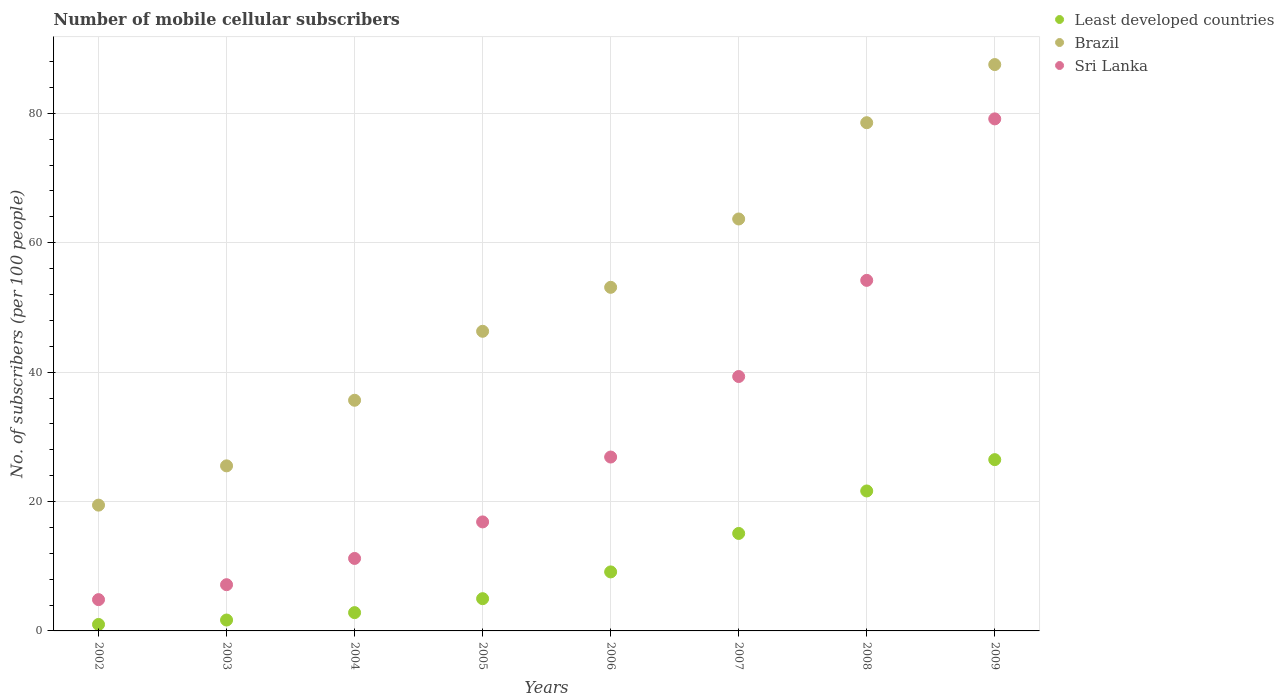How many different coloured dotlines are there?
Make the answer very short. 3. Is the number of dotlines equal to the number of legend labels?
Provide a succinct answer. Yes. What is the number of mobile cellular subscribers in Brazil in 2002?
Provide a succinct answer. 19.44. Across all years, what is the maximum number of mobile cellular subscribers in Sri Lanka?
Your answer should be very brief. 79.15. Across all years, what is the minimum number of mobile cellular subscribers in Least developed countries?
Provide a succinct answer. 1. In which year was the number of mobile cellular subscribers in Sri Lanka minimum?
Your answer should be very brief. 2002. What is the total number of mobile cellular subscribers in Least developed countries in the graph?
Provide a short and direct response. 82.79. What is the difference between the number of mobile cellular subscribers in Brazil in 2003 and that in 2005?
Provide a succinct answer. -20.8. What is the difference between the number of mobile cellular subscribers in Sri Lanka in 2004 and the number of mobile cellular subscribers in Brazil in 2003?
Your response must be concise. -14.31. What is the average number of mobile cellular subscribers in Sri Lanka per year?
Keep it short and to the point. 29.95. In the year 2003, what is the difference between the number of mobile cellular subscribers in Least developed countries and number of mobile cellular subscribers in Brazil?
Offer a terse response. -23.83. In how many years, is the number of mobile cellular subscribers in Brazil greater than 32?
Your response must be concise. 6. What is the ratio of the number of mobile cellular subscribers in Sri Lanka in 2006 to that in 2007?
Keep it short and to the point. 0.68. What is the difference between the highest and the second highest number of mobile cellular subscribers in Sri Lanka?
Your answer should be very brief. 24.96. What is the difference between the highest and the lowest number of mobile cellular subscribers in Least developed countries?
Your response must be concise. 25.47. How many years are there in the graph?
Make the answer very short. 8. What is the difference between two consecutive major ticks on the Y-axis?
Provide a short and direct response. 20. Are the values on the major ticks of Y-axis written in scientific E-notation?
Provide a short and direct response. No. Does the graph contain grids?
Offer a terse response. Yes. Where does the legend appear in the graph?
Provide a short and direct response. Top right. How many legend labels are there?
Offer a very short reply. 3. What is the title of the graph?
Offer a terse response. Number of mobile cellular subscribers. What is the label or title of the Y-axis?
Give a very brief answer. No. of subscribers (per 100 people). What is the No. of subscribers (per 100 people) in Least developed countries in 2002?
Provide a short and direct response. 1. What is the No. of subscribers (per 100 people) in Brazil in 2002?
Provide a succinct answer. 19.44. What is the No. of subscribers (per 100 people) in Sri Lanka in 2002?
Offer a very short reply. 4.84. What is the No. of subscribers (per 100 people) in Least developed countries in 2003?
Keep it short and to the point. 1.68. What is the No. of subscribers (per 100 people) of Brazil in 2003?
Your answer should be very brief. 25.51. What is the No. of subscribers (per 100 people) in Sri Lanka in 2003?
Provide a succinct answer. 7.14. What is the No. of subscribers (per 100 people) in Least developed countries in 2004?
Keep it short and to the point. 2.83. What is the No. of subscribers (per 100 people) in Brazil in 2004?
Keep it short and to the point. 35.65. What is the No. of subscribers (per 100 people) of Sri Lanka in 2004?
Your answer should be very brief. 11.2. What is the No. of subscribers (per 100 people) in Least developed countries in 2005?
Provide a short and direct response. 4.98. What is the No. of subscribers (per 100 people) in Brazil in 2005?
Provide a succinct answer. 46.31. What is the No. of subscribers (per 100 people) of Sri Lanka in 2005?
Your answer should be compact. 16.85. What is the No. of subscribers (per 100 people) in Least developed countries in 2006?
Provide a short and direct response. 9.12. What is the No. of subscribers (per 100 people) in Brazil in 2006?
Offer a very short reply. 53.11. What is the No. of subscribers (per 100 people) of Sri Lanka in 2006?
Provide a succinct answer. 26.88. What is the No. of subscribers (per 100 people) in Least developed countries in 2007?
Your answer should be very brief. 15.07. What is the No. of subscribers (per 100 people) of Brazil in 2007?
Your answer should be compact. 63.67. What is the No. of subscribers (per 100 people) in Sri Lanka in 2007?
Ensure brevity in your answer.  39.32. What is the No. of subscribers (per 100 people) of Least developed countries in 2008?
Your answer should be very brief. 21.63. What is the No. of subscribers (per 100 people) of Brazil in 2008?
Give a very brief answer. 78.55. What is the No. of subscribers (per 100 people) of Sri Lanka in 2008?
Your response must be concise. 54.19. What is the No. of subscribers (per 100 people) of Least developed countries in 2009?
Your answer should be very brief. 26.48. What is the No. of subscribers (per 100 people) in Brazil in 2009?
Provide a short and direct response. 87.54. What is the No. of subscribers (per 100 people) in Sri Lanka in 2009?
Ensure brevity in your answer.  79.15. Across all years, what is the maximum No. of subscribers (per 100 people) in Least developed countries?
Offer a terse response. 26.48. Across all years, what is the maximum No. of subscribers (per 100 people) in Brazil?
Provide a short and direct response. 87.54. Across all years, what is the maximum No. of subscribers (per 100 people) in Sri Lanka?
Provide a succinct answer. 79.15. Across all years, what is the minimum No. of subscribers (per 100 people) in Least developed countries?
Keep it short and to the point. 1. Across all years, what is the minimum No. of subscribers (per 100 people) of Brazil?
Your answer should be compact. 19.44. Across all years, what is the minimum No. of subscribers (per 100 people) in Sri Lanka?
Your response must be concise. 4.84. What is the total No. of subscribers (per 100 people) in Least developed countries in the graph?
Your answer should be very brief. 82.79. What is the total No. of subscribers (per 100 people) in Brazil in the graph?
Offer a terse response. 409.81. What is the total No. of subscribers (per 100 people) in Sri Lanka in the graph?
Offer a very short reply. 239.57. What is the difference between the No. of subscribers (per 100 people) in Least developed countries in 2002 and that in 2003?
Your response must be concise. -0.68. What is the difference between the No. of subscribers (per 100 people) of Brazil in 2002 and that in 2003?
Give a very brief answer. -6.07. What is the difference between the No. of subscribers (per 100 people) in Sri Lanka in 2002 and that in 2003?
Your answer should be compact. -2.31. What is the difference between the No. of subscribers (per 100 people) of Least developed countries in 2002 and that in 2004?
Your answer should be very brief. -1.83. What is the difference between the No. of subscribers (per 100 people) of Brazil in 2002 and that in 2004?
Your answer should be compact. -16.21. What is the difference between the No. of subscribers (per 100 people) in Sri Lanka in 2002 and that in 2004?
Your answer should be compact. -6.37. What is the difference between the No. of subscribers (per 100 people) of Least developed countries in 2002 and that in 2005?
Offer a terse response. -3.98. What is the difference between the No. of subscribers (per 100 people) in Brazil in 2002 and that in 2005?
Provide a succinct answer. -26.87. What is the difference between the No. of subscribers (per 100 people) in Sri Lanka in 2002 and that in 2005?
Your response must be concise. -12.01. What is the difference between the No. of subscribers (per 100 people) of Least developed countries in 2002 and that in 2006?
Offer a very short reply. -8.12. What is the difference between the No. of subscribers (per 100 people) in Brazil in 2002 and that in 2006?
Your response must be concise. -33.67. What is the difference between the No. of subscribers (per 100 people) in Sri Lanka in 2002 and that in 2006?
Your response must be concise. -22.04. What is the difference between the No. of subscribers (per 100 people) of Least developed countries in 2002 and that in 2007?
Offer a very short reply. -14.07. What is the difference between the No. of subscribers (per 100 people) of Brazil in 2002 and that in 2007?
Provide a short and direct response. -44.23. What is the difference between the No. of subscribers (per 100 people) of Sri Lanka in 2002 and that in 2007?
Provide a succinct answer. -34.49. What is the difference between the No. of subscribers (per 100 people) of Least developed countries in 2002 and that in 2008?
Give a very brief answer. -20.63. What is the difference between the No. of subscribers (per 100 people) of Brazil in 2002 and that in 2008?
Ensure brevity in your answer.  -59.11. What is the difference between the No. of subscribers (per 100 people) in Sri Lanka in 2002 and that in 2008?
Your answer should be compact. -49.35. What is the difference between the No. of subscribers (per 100 people) in Least developed countries in 2002 and that in 2009?
Offer a very short reply. -25.47. What is the difference between the No. of subscribers (per 100 people) of Brazil in 2002 and that in 2009?
Give a very brief answer. -68.1. What is the difference between the No. of subscribers (per 100 people) in Sri Lanka in 2002 and that in 2009?
Make the answer very short. -74.31. What is the difference between the No. of subscribers (per 100 people) of Least developed countries in 2003 and that in 2004?
Ensure brevity in your answer.  -1.14. What is the difference between the No. of subscribers (per 100 people) of Brazil in 2003 and that in 2004?
Provide a short and direct response. -10.14. What is the difference between the No. of subscribers (per 100 people) in Sri Lanka in 2003 and that in 2004?
Your answer should be very brief. -4.06. What is the difference between the No. of subscribers (per 100 people) in Least developed countries in 2003 and that in 2005?
Keep it short and to the point. -3.3. What is the difference between the No. of subscribers (per 100 people) in Brazil in 2003 and that in 2005?
Provide a short and direct response. -20.8. What is the difference between the No. of subscribers (per 100 people) of Sri Lanka in 2003 and that in 2005?
Your response must be concise. -9.71. What is the difference between the No. of subscribers (per 100 people) of Least developed countries in 2003 and that in 2006?
Your response must be concise. -7.44. What is the difference between the No. of subscribers (per 100 people) in Brazil in 2003 and that in 2006?
Offer a terse response. -27.6. What is the difference between the No. of subscribers (per 100 people) of Sri Lanka in 2003 and that in 2006?
Provide a succinct answer. -19.73. What is the difference between the No. of subscribers (per 100 people) in Least developed countries in 2003 and that in 2007?
Offer a terse response. -13.38. What is the difference between the No. of subscribers (per 100 people) of Brazil in 2003 and that in 2007?
Provide a succinct answer. -38.16. What is the difference between the No. of subscribers (per 100 people) in Sri Lanka in 2003 and that in 2007?
Give a very brief answer. -32.18. What is the difference between the No. of subscribers (per 100 people) of Least developed countries in 2003 and that in 2008?
Make the answer very short. -19.95. What is the difference between the No. of subscribers (per 100 people) of Brazil in 2003 and that in 2008?
Your answer should be very brief. -53.04. What is the difference between the No. of subscribers (per 100 people) of Sri Lanka in 2003 and that in 2008?
Your answer should be compact. -47.04. What is the difference between the No. of subscribers (per 100 people) of Least developed countries in 2003 and that in 2009?
Provide a short and direct response. -24.79. What is the difference between the No. of subscribers (per 100 people) in Brazil in 2003 and that in 2009?
Ensure brevity in your answer.  -62.03. What is the difference between the No. of subscribers (per 100 people) in Sri Lanka in 2003 and that in 2009?
Your answer should be compact. -72. What is the difference between the No. of subscribers (per 100 people) of Least developed countries in 2004 and that in 2005?
Make the answer very short. -2.16. What is the difference between the No. of subscribers (per 100 people) in Brazil in 2004 and that in 2005?
Give a very brief answer. -10.66. What is the difference between the No. of subscribers (per 100 people) of Sri Lanka in 2004 and that in 2005?
Offer a terse response. -5.65. What is the difference between the No. of subscribers (per 100 people) in Least developed countries in 2004 and that in 2006?
Your response must be concise. -6.29. What is the difference between the No. of subscribers (per 100 people) of Brazil in 2004 and that in 2006?
Give a very brief answer. -17.46. What is the difference between the No. of subscribers (per 100 people) in Sri Lanka in 2004 and that in 2006?
Make the answer very short. -15.67. What is the difference between the No. of subscribers (per 100 people) in Least developed countries in 2004 and that in 2007?
Your answer should be very brief. -12.24. What is the difference between the No. of subscribers (per 100 people) in Brazil in 2004 and that in 2007?
Provide a succinct answer. -28.02. What is the difference between the No. of subscribers (per 100 people) of Sri Lanka in 2004 and that in 2007?
Your response must be concise. -28.12. What is the difference between the No. of subscribers (per 100 people) of Least developed countries in 2004 and that in 2008?
Keep it short and to the point. -18.81. What is the difference between the No. of subscribers (per 100 people) of Brazil in 2004 and that in 2008?
Offer a very short reply. -42.9. What is the difference between the No. of subscribers (per 100 people) of Sri Lanka in 2004 and that in 2008?
Your answer should be very brief. -42.98. What is the difference between the No. of subscribers (per 100 people) in Least developed countries in 2004 and that in 2009?
Offer a very short reply. -23.65. What is the difference between the No. of subscribers (per 100 people) of Brazil in 2004 and that in 2009?
Your response must be concise. -51.89. What is the difference between the No. of subscribers (per 100 people) of Sri Lanka in 2004 and that in 2009?
Provide a succinct answer. -67.94. What is the difference between the No. of subscribers (per 100 people) of Least developed countries in 2005 and that in 2006?
Ensure brevity in your answer.  -4.14. What is the difference between the No. of subscribers (per 100 people) in Brazil in 2005 and that in 2006?
Offer a terse response. -6.8. What is the difference between the No. of subscribers (per 100 people) of Sri Lanka in 2005 and that in 2006?
Your response must be concise. -10.03. What is the difference between the No. of subscribers (per 100 people) in Least developed countries in 2005 and that in 2007?
Give a very brief answer. -10.08. What is the difference between the No. of subscribers (per 100 people) of Brazil in 2005 and that in 2007?
Offer a very short reply. -17.36. What is the difference between the No. of subscribers (per 100 people) of Sri Lanka in 2005 and that in 2007?
Make the answer very short. -22.47. What is the difference between the No. of subscribers (per 100 people) in Least developed countries in 2005 and that in 2008?
Your answer should be compact. -16.65. What is the difference between the No. of subscribers (per 100 people) in Brazil in 2005 and that in 2008?
Make the answer very short. -32.24. What is the difference between the No. of subscribers (per 100 people) of Sri Lanka in 2005 and that in 2008?
Give a very brief answer. -37.34. What is the difference between the No. of subscribers (per 100 people) of Least developed countries in 2005 and that in 2009?
Ensure brevity in your answer.  -21.49. What is the difference between the No. of subscribers (per 100 people) in Brazil in 2005 and that in 2009?
Keep it short and to the point. -41.23. What is the difference between the No. of subscribers (per 100 people) of Sri Lanka in 2005 and that in 2009?
Provide a short and direct response. -62.3. What is the difference between the No. of subscribers (per 100 people) of Least developed countries in 2006 and that in 2007?
Offer a very short reply. -5.95. What is the difference between the No. of subscribers (per 100 people) of Brazil in 2006 and that in 2007?
Your answer should be very brief. -10.56. What is the difference between the No. of subscribers (per 100 people) in Sri Lanka in 2006 and that in 2007?
Your response must be concise. -12.45. What is the difference between the No. of subscribers (per 100 people) of Least developed countries in 2006 and that in 2008?
Offer a very short reply. -12.51. What is the difference between the No. of subscribers (per 100 people) of Brazil in 2006 and that in 2008?
Your response must be concise. -25.44. What is the difference between the No. of subscribers (per 100 people) in Sri Lanka in 2006 and that in 2008?
Ensure brevity in your answer.  -27.31. What is the difference between the No. of subscribers (per 100 people) in Least developed countries in 2006 and that in 2009?
Offer a terse response. -17.35. What is the difference between the No. of subscribers (per 100 people) of Brazil in 2006 and that in 2009?
Your answer should be compact. -34.43. What is the difference between the No. of subscribers (per 100 people) in Sri Lanka in 2006 and that in 2009?
Provide a short and direct response. -52.27. What is the difference between the No. of subscribers (per 100 people) in Least developed countries in 2007 and that in 2008?
Offer a very short reply. -6.57. What is the difference between the No. of subscribers (per 100 people) in Brazil in 2007 and that in 2008?
Provide a succinct answer. -14.88. What is the difference between the No. of subscribers (per 100 people) of Sri Lanka in 2007 and that in 2008?
Your response must be concise. -14.86. What is the difference between the No. of subscribers (per 100 people) in Least developed countries in 2007 and that in 2009?
Ensure brevity in your answer.  -11.41. What is the difference between the No. of subscribers (per 100 people) in Brazil in 2007 and that in 2009?
Provide a short and direct response. -23.87. What is the difference between the No. of subscribers (per 100 people) in Sri Lanka in 2007 and that in 2009?
Give a very brief answer. -39.82. What is the difference between the No. of subscribers (per 100 people) of Least developed countries in 2008 and that in 2009?
Offer a very short reply. -4.84. What is the difference between the No. of subscribers (per 100 people) in Brazil in 2008 and that in 2009?
Provide a succinct answer. -8.99. What is the difference between the No. of subscribers (per 100 people) in Sri Lanka in 2008 and that in 2009?
Your response must be concise. -24.96. What is the difference between the No. of subscribers (per 100 people) of Least developed countries in 2002 and the No. of subscribers (per 100 people) of Brazil in 2003?
Offer a terse response. -24.51. What is the difference between the No. of subscribers (per 100 people) in Least developed countries in 2002 and the No. of subscribers (per 100 people) in Sri Lanka in 2003?
Ensure brevity in your answer.  -6.14. What is the difference between the No. of subscribers (per 100 people) in Brazil in 2002 and the No. of subscribers (per 100 people) in Sri Lanka in 2003?
Provide a succinct answer. 12.3. What is the difference between the No. of subscribers (per 100 people) in Least developed countries in 2002 and the No. of subscribers (per 100 people) in Brazil in 2004?
Make the answer very short. -34.65. What is the difference between the No. of subscribers (per 100 people) of Least developed countries in 2002 and the No. of subscribers (per 100 people) of Sri Lanka in 2004?
Your answer should be very brief. -10.2. What is the difference between the No. of subscribers (per 100 people) of Brazil in 2002 and the No. of subscribers (per 100 people) of Sri Lanka in 2004?
Ensure brevity in your answer.  8.24. What is the difference between the No. of subscribers (per 100 people) of Least developed countries in 2002 and the No. of subscribers (per 100 people) of Brazil in 2005?
Give a very brief answer. -45.31. What is the difference between the No. of subscribers (per 100 people) in Least developed countries in 2002 and the No. of subscribers (per 100 people) in Sri Lanka in 2005?
Keep it short and to the point. -15.85. What is the difference between the No. of subscribers (per 100 people) of Brazil in 2002 and the No. of subscribers (per 100 people) of Sri Lanka in 2005?
Provide a succinct answer. 2.59. What is the difference between the No. of subscribers (per 100 people) in Least developed countries in 2002 and the No. of subscribers (per 100 people) in Brazil in 2006?
Your answer should be very brief. -52.11. What is the difference between the No. of subscribers (per 100 people) of Least developed countries in 2002 and the No. of subscribers (per 100 people) of Sri Lanka in 2006?
Offer a very short reply. -25.88. What is the difference between the No. of subscribers (per 100 people) of Brazil in 2002 and the No. of subscribers (per 100 people) of Sri Lanka in 2006?
Make the answer very short. -7.43. What is the difference between the No. of subscribers (per 100 people) of Least developed countries in 2002 and the No. of subscribers (per 100 people) of Brazil in 2007?
Provide a succinct answer. -62.67. What is the difference between the No. of subscribers (per 100 people) of Least developed countries in 2002 and the No. of subscribers (per 100 people) of Sri Lanka in 2007?
Give a very brief answer. -38.32. What is the difference between the No. of subscribers (per 100 people) in Brazil in 2002 and the No. of subscribers (per 100 people) in Sri Lanka in 2007?
Keep it short and to the point. -19.88. What is the difference between the No. of subscribers (per 100 people) of Least developed countries in 2002 and the No. of subscribers (per 100 people) of Brazil in 2008?
Provide a short and direct response. -77.55. What is the difference between the No. of subscribers (per 100 people) in Least developed countries in 2002 and the No. of subscribers (per 100 people) in Sri Lanka in 2008?
Provide a succinct answer. -53.19. What is the difference between the No. of subscribers (per 100 people) in Brazil in 2002 and the No. of subscribers (per 100 people) in Sri Lanka in 2008?
Your response must be concise. -34.74. What is the difference between the No. of subscribers (per 100 people) in Least developed countries in 2002 and the No. of subscribers (per 100 people) in Brazil in 2009?
Provide a short and direct response. -86.54. What is the difference between the No. of subscribers (per 100 people) of Least developed countries in 2002 and the No. of subscribers (per 100 people) of Sri Lanka in 2009?
Make the answer very short. -78.15. What is the difference between the No. of subscribers (per 100 people) of Brazil in 2002 and the No. of subscribers (per 100 people) of Sri Lanka in 2009?
Make the answer very short. -59.7. What is the difference between the No. of subscribers (per 100 people) of Least developed countries in 2003 and the No. of subscribers (per 100 people) of Brazil in 2004?
Offer a terse response. -33.97. What is the difference between the No. of subscribers (per 100 people) in Least developed countries in 2003 and the No. of subscribers (per 100 people) in Sri Lanka in 2004?
Provide a short and direct response. -9.52. What is the difference between the No. of subscribers (per 100 people) in Brazil in 2003 and the No. of subscribers (per 100 people) in Sri Lanka in 2004?
Your answer should be very brief. 14.31. What is the difference between the No. of subscribers (per 100 people) in Least developed countries in 2003 and the No. of subscribers (per 100 people) in Brazil in 2005?
Your response must be concise. -44.63. What is the difference between the No. of subscribers (per 100 people) in Least developed countries in 2003 and the No. of subscribers (per 100 people) in Sri Lanka in 2005?
Offer a very short reply. -15.17. What is the difference between the No. of subscribers (per 100 people) in Brazil in 2003 and the No. of subscribers (per 100 people) in Sri Lanka in 2005?
Provide a short and direct response. 8.66. What is the difference between the No. of subscribers (per 100 people) of Least developed countries in 2003 and the No. of subscribers (per 100 people) of Brazil in 2006?
Your response must be concise. -51.43. What is the difference between the No. of subscribers (per 100 people) of Least developed countries in 2003 and the No. of subscribers (per 100 people) of Sri Lanka in 2006?
Provide a short and direct response. -25.19. What is the difference between the No. of subscribers (per 100 people) of Brazil in 2003 and the No. of subscribers (per 100 people) of Sri Lanka in 2006?
Your response must be concise. -1.36. What is the difference between the No. of subscribers (per 100 people) in Least developed countries in 2003 and the No. of subscribers (per 100 people) in Brazil in 2007?
Give a very brief answer. -61.99. What is the difference between the No. of subscribers (per 100 people) in Least developed countries in 2003 and the No. of subscribers (per 100 people) in Sri Lanka in 2007?
Your response must be concise. -37.64. What is the difference between the No. of subscribers (per 100 people) of Brazil in 2003 and the No. of subscribers (per 100 people) of Sri Lanka in 2007?
Provide a succinct answer. -13.81. What is the difference between the No. of subscribers (per 100 people) of Least developed countries in 2003 and the No. of subscribers (per 100 people) of Brazil in 2008?
Offer a terse response. -76.87. What is the difference between the No. of subscribers (per 100 people) in Least developed countries in 2003 and the No. of subscribers (per 100 people) in Sri Lanka in 2008?
Make the answer very short. -52.5. What is the difference between the No. of subscribers (per 100 people) of Brazil in 2003 and the No. of subscribers (per 100 people) of Sri Lanka in 2008?
Ensure brevity in your answer.  -28.67. What is the difference between the No. of subscribers (per 100 people) of Least developed countries in 2003 and the No. of subscribers (per 100 people) of Brazil in 2009?
Your response must be concise. -85.86. What is the difference between the No. of subscribers (per 100 people) of Least developed countries in 2003 and the No. of subscribers (per 100 people) of Sri Lanka in 2009?
Your answer should be compact. -77.46. What is the difference between the No. of subscribers (per 100 people) in Brazil in 2003 and the No. of subscribers (per 100 people) in Sri Lanka in 2009?
Offer a very short reply. -53.63. What is the difference between the No. of subscribers (per 100 people) in Least developed countries in 2004 and the No. of subscribers (per 100 people) in Brazil in 2005?
Ensure brevity in your answer.  -43.49. What is the difference between the No. of subscribers (per 100 people) in Least developed countries in 2004 and the No. of subscribers (per 100 people) in Sri Lanka in 2005?
Your answer should be very brief. -14.02. What is the difference between the No. of subscribers (per 100 people) in Brazil in 2004 and the No. of subscribers (per 100 people) in Sri Lanka in 2005?
Keep it short and to the point. 18.8. What is the difference between the No. of subscribers (per 100 people) of Least developed countries in 2004 and the No. of subscribers (per 100 people) of Brazil in 2006?
Make the answer very short. -50.28. What is the difference between the No. of subscribers (per 100 people) in Least developed countries in 2004 and the No. of subscribers (per 100 people) in Sri Lanka in 2006?
Provide a short and direct response. -24.05. What is the difference between the No. of subscribers (per 100 people) in Brazil in 2004 and the No. of subscribers (per 100 people) in Sri Lanka in 2006?
Give a very brief answer. 8.78. What is the difference between the No. of subscribers (per 100 people) of Least developed countries in 2004 and the No. of subscribers (per 100 people) of Brazil in 2007?
Your answer should be very brief. -60.85. What is the difference between the No. of subscribers (per 100 people) of Least developed countries in 2004 and the No. of subscribers (per 100 people) of Sri Lanka in 2007?
Offer a terse response. -36.5. What is the difference between the No. of subscribers (per 100 people) in Brazil in 2004 and the No. of subscribers (per 100 people) in Sri Lanka in 2007?
Offer a very short reply. -3.67. What is the difference between the No. of subscribers (per 100 people) in Least developed countries in 2004 and the No. of subscribers (per 100 people) in Brazil in 2008?
Provide a short and direct response. -75.73. What is the difference between the No. of subscribers (per 100 people) in Least developed countries in 2004 and the No. of subscribers (per 100 people) in Sri Lanka in 2008?
Your response must be concise. -51.36. What is the difference between the No. of subscribers (per 100 people) in Brazil in 2004 and the No. of subscribers (per 100 people) in Sri Lanka in 2008?
Give a very brief answer. -18.53. What is the difference between the No. of subscribers (per 100 people) of Least developed countries in 2004 and the No. of subscribers (per 100 people) of Brazil in 2009?
Offer a terse response. -84.72. What is the difference between the No. of subscribers (per 100 people) of Least developed countries in 2004 and the No. of subscribers (per 100 people) of Sri Lanka in 2009?
Your answer should be very brief. -76.32. What is the difference between the No. of subscribers (per 100 people) of Brazil in 2004 and the No. of subscribers (per 100 people) of Sri Lanka in 2009?
Ensure brevity in your answer.  -43.49. What is the difference between the No. of subscribers (per 100 people) in Least developed countries in 2005 and the No. of subscribers (per 100 people) in Brazil in 2006?
Give a very brief answer. -48.13. What is the difference between the No. of subscribers (per 100 people) in Least developed countries in 2005 and the No. of subscribers (per 100 people) in Sri Lanka in 2006?
Ensure brevity in your answer.  -21.89. What is the difference between the No. of subscribers (per 100 people) of Brazil in 2005 and the No. of subscribers (per 100 people) of Sri Lanka in 2006?
Provide a short and direct response. 19.44. What is the difference between the No. of subscribers (per 100 people) of Least developed countries in 2005 and the No. of subscribers (per 100 people) of Brazil in 2007?
Your answer should be compact. -58.69. What is the difference between the No. of subscribers (per 100 people) of Least developed countries in 2005 and the No. of subscribers (per 100 people) of Sri Lanka in 2007?
Your answer should be very brief. -34.34. What is the difference between the No. of subscribers (per 100 people) of Brazil in 2005 and the No. of subscribers (per 100 people) of Sri Lanka in 2007?
Ensure brevity in your answer.  6.99. What is the difference between the No. of subscribers (per 100 people) in Least developed countries in 2005 and the No. of subscribers (per 100 people) in Brazil in 2008?
Your answer should be very brief. -73.57. What is the difference between the No. of subscribers (per 100 people) in Least developed countries in 2005 and the No. of subscribers (per 100 people) in Sri Lanka in 2008?
Give a very brief answer. -49.2. What is the difference between the No. of subscribers (per 100 people) of Brazil in 2005 and the No. of subscribers (per 100 people) of Sri Lanka in 2008?
Ensure brevity in your answer.  -7.87. What is the difference between the No. of subscribers (per 100 people) in Least developed countries in 2005 and the No. of subscribers (per 100 people) in Brazil in 2009?
Ensure brevity in your answer.  -82.56. What is the difference between the No. of subscribers (per 100 people) in Least developed countries in 2005 and the No. of subscribers (per 100 people) in Sri Lanka in 2009?
Ensure brevity in your answer.  -74.16. What is the difference between the No. of subscribers (per 100 people) in Brazil in 2005 and the No. of subscribers (per 100 people) in Sri Lanka in 2009?
Make the answer very short. -32.83. What is the difference between the No. of subscribers (per 100 people) of Least developed countries in 2006 and the No. of subscribers (per 100 people) of Brazil in 2007?
Ensure brevity in your answer.  -54.55. What is the difference between the No. of subscribers (per 100 people) in Least developed countries in 2006 and the No. of subscribers (per 100 people) in Sri Lanka in 2007?
Make the answer very short. -30.2. What is the difference between the No. of subscribers (per 100 people) of Brazil in 2006 and the No. of subscribers (per 100 people) of Sri Lanka in 2007?
Keep it short and to the point. 13.79. What is the difference between the No. of subscribers (per 100 people) of Least developed countries in 2006 and the No. of subscribers (per 100 people) of Brazil in 2008?
Offer a very short reply. -69.43. What is the difference between the No. of subscribers (per 100 people) in Least developed countries in 2006 and the No. of subscribers (per 100 people) in Sri Lanka in 2008?
Provide a short and direct response. -45.07. What is the difference between the No. of subscribers (per 100 people) of Brazil in 2006 and the No. of subscribers (per 100 people) of Sri Lanka in 2008?
Give a very brief answer. -1.08. What is the difference between the No. of subscribers (per 100 people) in Least developed countries in 2006 and the No. of subscribers (per 100 people) in Brazil in 2009?
Your response must be concise. -78.42. What is the difference between the No. of subscribers (per 100 people) of Least developed countries in 2006 and the No. of subscribers (per 100 people) of Sri Lanka in 2009?
Offer a terse response. -70.02. What is the difference between the No. of subscribers (per 100 people) of Brazil in 2006 and the No. of subscribers (per 100 people) of Sri Lanka in 2009?
Provide a succinct answer. -26.04. What is the difference between the No. of subscribers (per 100 people) of Least developed countries in 2007 and the No. of subscribers (per 100 people) of Brazil in 2008?
Give a very brief answer. -63.49. What is the difference between the No. of subscribers (per 100 people) in Least developed countries in 2007 and the No. of subscribers (per 100 people) in Sri Lanka in 2008?
Give a very brief answer. -39.12. What is the difference between the No. of subscribers (per 100 people) in Brazil in 2007 and the No. of subscribers (per 100 people) in Sri Lanka in 2008?
Ensure brevity in your answer.  9.49. What is the difference between the No. of subscribers (per 100 people) in Least developed countries in 2007 and the No. of subscribers (per 100 people) in Brazil in 2009?
Your answer should be compact. -72.47. What is the difference between the No. of subscribers (per 100 people) in Least developed countries in 2007 and the No. of subscribers (per 100 people) in Sri Lanka in 2009?
Provide a succinct answer. -64.08. What is the difference between the No. of subscribers (per 100 people) of Brazil in 2007 and the No. of subscribers (per 100 people) of Sri Lanka in 2009?
Your answer should be compact. -15.47. What is the difference between the No. of subscribers (per 100 people) of Least developed countries in 2008 and the No. of subscribers (per 100 people) of Brazil in 2009?
Make the answer very short. -65.91. What is the difference between the No. of subscribers (per 100 people) of Least developed countries in 2008 and the No. of subscribers (per 100 people) of Sri Lanka in 2009?
Your answer should be compact. -57.51. What is the difference between the No. of subscribers (per 100 people) in Brazil in 2008 and the No. of subscribers (per 100 people) in Sri Lanka in 2009?
Give a very brief answer. -0.59. What is the average No. of subscribers (per 100 people) of Least developed countries per year?
Provide a succinct answer. 10.35. What is the average No. of subscribers (per 100 people) in Brazil per year?
Ensure brevity in your answer.  51.23. What is the average No. of subscribers (per 100 people) of Sri Lanka per year?
Your response must be concise. 29.95. In the year 2002, what is the difference between the No. of subscribers (per 100 people) in Least developed countries and No. of subscribers (per 100 people) in Brazil?
Your answer should be very brief. -18.44. In the year 2002, what is the difference between the No. of subscribers (per 100 people) in Least developed countries and No. of subscribers (per 100 people) in Sri Lanka?
Provide a short and direct response. -3.84. In the year 2002, what is the difference between the No. of subscribers (per 100 people) of Brazil and No. of subscribers (per 100 people) of Sri Lanka?
Your answer should be very brief. 14.61. In the year 2003, what is the difference between the No. of subscribers (per 100 people) of Least developed countries and No. of subscribers (per 100 people) of Brazil?
Make the answer very short. -23.83. In the year 2003, what is the difference between the No. of subscribers (per 100 people) of Least developed countries and No. of subscribers (per 100 people) of Sri Lanka?
Ensure brevity in your answer.  -5.46. In the year 2003, what is the difference between the No. of subscribers (per 100 people) of Brazil and No. of subscribers (per 100 people) of Sri Lanka?
Ensure brevity in your answer.  18.37. In the year 2004, what is the difference between the No. of subscribers (per 100 people) in Least developed countries and No. of subscribers (per 100 people) in Brazil?
Ensure brevity in your answer.  -32.83. In the year 2004, what is the difference between the No. of subscribers (per 100 people) in Least developed countries and No. of subscribers (per 100 people) in Sri Lanka?
Ensure brevity in your answer.  -8.38. In the year 2004, what is the difference between the No. of subscribers (per 100 people) in Brazil and No. of subscribers (per 100 people) in Sri Lanka?
Your response must be concise. 24.45. In the year 2005, what is the difference between the No. of subscribers (per 100 people) of Least developed countries and No. of subscribers (per 100 people) of Brazil?
Provide a succinct answer. -41.33. In the year 2005, what is the difference between the No. of subscribers (per 100 people) in Least developed countries and No. of subscribers (per 100 people) in Sri Lanka?
Keep it short and to the point. -11.87. In the year 2005, what is the difference between the No. of subscribers (per 100 people) of Brazil and No. of subscribers (per 100 people) of Sri Lanka?
Provide a succinct answer. 29.46. In the year 2006, what is the difference between the No. of subscribers (per 100 people) of Least developed countries and No. of subscribers (per 100 people) of Brazil?
Offer a very short reply. -43.99. In the year 2006, what is the difference between the No. of subscribers (per 100 people) in Least developed countries and No. of subscribers (per 100 people) in Sri Lanka?
Make the answer very short. -17.76. In the year 2006, what is the difference between the No. of subscribers (per 100 people) of Brazil and No. of subscribers (per 100 people) of Sri Lanka?
Give a very brief answer. 26.23. In the year 2007, what is the difference between the No. of subscribers (per 100 people) in Least developed countries and No. of subscribers (per 100 people) in Brazil?
Provide a short and direct response. -48.61. In the year 2007, what is the difference between the No. of subscribers (per 100 people) in Least developed countries and No. of subscribers (per 100 people) in Sri Lanka?
Your answer should be compact. -24.26. In the year 2007, what is the difference between the No. of subscribers (per 100 people) in Brazil and No. of subscribers (per 100 people) in Sri Lanka?
Offer a very short reply. 24.35. In the year 2008, what is the difference between the No. of subscribers (per 100 people) in Least developed countries and No. of subscribers (per 100 people) in Brazil?
Give a very brief answer. -56.92. In the year 2008, what is the difference between the No. of subscribers (per 100 people) in Least developed countries and No. of subscribers (per 100 people) in Sri Lanka?
Keep it short and to the point. -32.55. In the year 2008, what is the difference between the No. of subscribers (per 100 people) in Brazil and No. of subscribers (per 100 people) in Sri Lanka?
Your answer should be compact. 24.37. In the year 2009, what is the difference between the No. of subscribers (per 100 people) of Least developed countries and No. of subscribers (per 100 people) of Brazil?
Your answer should be compact. -61.07. In the year 2009, what is the difference between the No. of subscribers (per 100 people) in Least developed countries and No. of subscribers (per 100 people) in Sri Lanka?
Offer a terse response. -52.67. In the year 2009, what is the difference between the No. of subscribers (per 100 people) of Brazil and No. of subscribers (per 100 people) of Sri Lanka?
Provide a succinct answer. 8.4. What is the ratio of the No. of subscribers (per 100 people) of Least developed countries in 2002 to that in 2003?
Provide a short and direct response. 0.59. What is the ratio of the No. of subscribers (per 100 people) of Brazil in 2002 to that in 2003?
Offer a very short reply. 0.76. What is the ratio of the No. of subscribers (per 100 people) of Sri Lanka in 2002 to that in 2003?
Make the answer very short. 0.68. What is the ratio of the No. of subscribers (per 100 people) of Least developed countries in 2002 to that in 2004?
Your response must be concise. 0.35. What is the ratio of the No. of subscribers (per 100 people) of Brazil in 2002 to that in 2004?
Make the answer very short. 0.55. What is the ratio of the No. of subscribers (per 100 people) in Sri Lanka in 2002 to that in 2004?
Ensure brevity in your answer.  0.43. What is the ratio of the No. of subscribers (per 100 people) in Least developed countries in 2002 to that in 2005?
Provide a short and direct response. 0.2. What is the ratio of the No. of subscribers (per 100 people) of Brazil in 2002 to that in 2005?
Keep it short and to the point. 0.42. What is the ratio of the No. of subscribers (per 100 people) in Sri Lanka in 2002 to that in 2005?
Your response must be concise. 0.29. What is the ratio of the No. of subscribers (per 100 people) of Least developed countries in 2002 to that in 2006?
Give a very brief answer. 0.11. What is the ratio of the No. of subscribers (per 100 people) of Brazil in 2002 to that in 2006?
Ensure brevity in your answer.  0.37. What is the ratio of the No. of subscribers (per 100 people) in Sri Lanka in 2002 to that in 2006?
Provide a succinct answer. 0.18. What is the ratio of the No. of subscribers (per 100 people) in Least developed countries in 2002 to that in 2007?
Your response must be concise. 0.07. What is the ratio of the No. of subscribers (per 100 people) of Brazil in 2002 to that in 2007?
Give a very brief answer. 0.31. What is the ratio of the No. of subscribers (per 100 people) of Sri Lanka in 2002 to that in 2007?
Give a very brief answer. 0.12. What is the ratio of the No. of subscribers (per 100 people) in Least developed countries in 2002 to that in 2008?
Provide a short and direct response. 0.05. What is the ratio of the No. of subscribers (per 100 people) of Brazil in 2002 to that in 2008?
Your answer should be compact. 0.25. What is the ratio of the No. of subscribers (per 100 people) in Sri Lanka in 2002 to that in 2008?
Keep it short and to the point. 0.09. What is the ratio of the No. of subscribers (per 100 people) of Least developed countries in 2002 to that in 2009?
Give a very brief answer. 0.04. What is the ratio of the No. of subscribers (per 100 people) of Brazil in 2002 to that in 2009?
Give a very brief answer. 0.22. What is the ratio of the No. of subscribers (per 100 people) in Sri Lanka in 2002 to that in 2009?
Give a very brief answer. 0.06. What is the ratio of the No. of subscribers (per 100 people) in Least developed countries in 2003 to that in 2004?
Provide a succinct answer. 0.6. What is the ratio of the No. of subscribers (per 100 people) of Brazil in 2003 to that in 2004?
Offer a terse response. 0.72. What is the ratio of the No. of subscribers (per 100 people) in Sri Lanka in 2003 to that in 2004?
Provide a short and direct response. 0.64. What is the ratio of the No. of subscribers (per 100 people) of Least developed countries in 2003 to that in 2005?
Offer a terse response. 0.34. What is the ratio of the No. of subscribers (per 100 people) of Brazil in 2003 to that in 2005?
Provide a short and direct response. 0.55. What is the ratio of the No. of subscribers (per 100 people) of Sri Lanka in 2003 to that in 2005?
Make the answer very short. 0.42. What is the ratio of the No. of subscribers (per 100 people) of Least developed countries in 2003 to that in 2006?
Give a very brief answer. 0.18. What is the ratio of the No. of subscribers (per 100 people) of Brazil in 2003 to that in 2006?
Keep it short and to the point. 0.48. What is the ratio of the No. of subscribers (per 100 people) in Sri Lanka in 2003 to that in 2006?
Your response must be concise. 0.27. What is the ratio of the No. of subscribers (per 100 people) of Least developed countries in 2003 to that in 2007?
Make the answer very short. 0.11. What is the ratio of the No. of subscribers (per 100 people) of Brazil in 2003 to that in 2007?
Make the answer very short. 0.4. What is the ratio of the No. of subscribers (per 100 people) in Sri Lanka in 2003 to that in 2007?
Keep it short and to the point. 0.18. What is the ratio of the No. of subscribers (per 100 people) of Least developed countries in 2003 to that in 2008?
Ensure brevity in your answer.  0.08. What is the ratio of the No. of subscribers (per 100 people) of Brazil in 2003 to that in 2008?
Ensure brevity in your answer.  0.32. What is the ratio of the No. of subscribers (per 100 people) in Sri Lanka in 2003 to that in 2008?
Your response must be concise. 0.13. What is the ratio of the No. of subscribers (per 100 people) of Least developed countries in 2003 to that in 2009?
Your response must be concise. 0.06. What is the ratio of the No. of subscribers (per 100 people) of Brazil in 2003 to that in 2009?
Your response must be concise. 0.29. What is the ratio of the No. of subscribers (per 100 people) in Sri Lanka in 2003 to that in 2009?
Make the answer very short. 0.09. What is the ratio of the No. of subscribers (per 100 people) of Least developed countries in 2004 to that in 2005?
Give a very brief answer. 0.57. What is the ratio of the No. of subscribers (per 100 people) of Brazil in 2004 to that in 2005?
Make the answer very short. 0.77. What is the ratio of the No. of subscribers (per 100 people) of Sri Lanka in 2004 to that in 2005?
Your response must be concise. 0.66. What is the ratio of the No. of subscribers (per 100 people) of Least developed countries in 2004 to that in 2006?
Give a very brief answer. 0.31. What is the ratio of the No. of subscribers (per 100 people) of Brazil in 2004 to that in 2006?
Provide a short and direct response. 0.67. What is the ratio of the No. of subscribers (per 100 people) in Sri Lanka in 2004 to that in 2006?
Make the answer very short. 0.42. What is the ratio of the No. of subscribers (per 100 people) of Least developed countries in 2004 to that in 2007?
Your response must be concise. 0.19. What is the ratio of the No. of subscribers (per 100 people) of Brazil in 2004 to that in 2007?
Offer a very short reply. 0.56. What is the ratio of the No. of subscribers (per 100 people) in Sri Lanka in 2004 to that in 2007?
Make the answer very short. 0.28. What is the ratio of the No. of subscribers (per 100 people) of Least developed countries in 2004 to that in 2008?
Your answer should be compact. 0.13. What is the ratio of the No. of subscribers (per 100 people) of Brazil in 2004 to that in 2008?
Offer a very short reply. 0.45. What is the ratio of the No. of subscribers (per 100 people) in Sri Lanka in 2004 to that in 2008?
Your answer should be compact. 0.21. What is the ratio of the No. of subscribers (per 100 people) in Least developed countries in 2004 to that in 2009?
Your response must be concise. 0.11. What is the ratio of the No. of subscribers (per 100 people) of Brazil in 2004 to that in 2009?
Give a very brief answer. 0.41. What is the ratio of the No. of subscribers (per 100 people) of Sri Lanka in 2004 to that in 2009?
Ensure brevity in your answer.  0.14. What is the ratio of the No. of subscribers (per 100 people) in Least developed countries in 2005 to that in 2006?
Offer a very short reply. 0.55. What is the ratio of the No. of subscribers (per 100 people) in Brazil in 2005 to that in 2006?
Provide a succinct answer. 0.87. What is the ratio of the No. of subscribers (per 100 people) of Sri Lanka in 2005 to that in 2006?
Ensure brevity in your answer.  0.63. What is the ratio of the No. of subscribers (per 100 people) in Least developed countries in 2005 to that in 2007?
Provide a short and direct response. 0.33. What is the ratio of the No. of subscribers (per 100 people) in Brazil in 2005 to that in 2007?
Offer a terse response. 0.73. What is the ratio of the No. of subscribers (per 100 people) of Sri Lanka in 2005 to that in 2007?
Your answer should be compact. 0.43. What is the ratio of the No. of subscribers (per 100 people) in Least developed countries in 2005 to that in 2008?
Provide a succinct answer. 0.23. What is the ratio of the No. of subscribers (per 100 people) in Brazil in 2005 to that in 2008?
Your response must be concise. 0.59. What is the ratio of the No. of subscribers (per 100 people) of Sri Lanka in 2005 to that in 2008?
Provide a short and direct response. 0.31. What is the ratio of the No. of subscribers (per 100 people) in Least developed countries in 2005 to that in 2009?
Give a very brief answer. 0.19. What is the ratio of the No. of subscribers (per 100 people) in Brazil in 2005 to that in 2009?
Your answer should be very brief. 0.53. What is the ratio of the No. of subscribers (per 100 people) in Sri Lanka in 2005 to that in 2009?
Your response must be concise. 0.21. What is the ratio of the No. of subscribers (per 100 people) in Least developed countries in 2006 to that in 2007?
Ensure brevity in your answer.  0.61. What is the ratio of the No. of subscribers (per 100 people) of Brazil in 2006 to that in 2007?
Offer a terse response. 0.83. What is the ratio of the No. of subscribers (per 100 people) of Sri Lanka in 2006 to that in 2007?
Provide a short and direct response. 0.68. What is the ratio of the No. of subscribers (per 100 people) of Least developed countries in 2006 to that in 2008?
Give a very brief answer. 0.42. What is the ratio of the No. of subscribers (per 100 people) of Brazil in 2006 to that in 2008?
Make the answer very short. 0.68. What is the ratio of the No. of subscribers (per 100 people) in Sri Lanka in 2006 to that in 2008?
Provide a short and direct response. 0.5. What is the ratio of the No. of subscribers (per 100 people) of Least developed countries in 2006 to that in 2009?
Your answer should be very brief. 0.34. What is the ratio of the No. of subscribers (per 100 people) in Brazil in 2006 to that in 2009?
Your answer should be very brief. 0.61. What is the ratio of the No. of subscribers (per 100 people) in Sri Lanka in 2006 to that in 2009?
Provide a short and direct response. 0.34. What is the ratio of the No. of subscribers (per 100 people) of Least developed countries in 2007 to that in 2008?
Offer a very short reply. 0.7. What is the ratio of the No. of subscribers (per 100 people) in Brazil in 2007 to that in 2008?
Your answer should be very brief. 0.81. What is the ratio of the No. of subscribers (per 100 people) in Sri Lanka in 2007 to that in 2008?
Offer a very short reply. 0.73. What is the ratio of the No. of subscribers (per 100 people) of Least developed countries in 2007 to that in 2009?
Make the answer very short. 0.57. What is the ratio of the No. of subscribers (per 100 people) of Brazil in 2007 to that in 2009?
Keep it short and to the point. 0.73. What is the ratio of the No. of subscribers (per 100 people) of Sri Lanka in 2007 to that in 2009?
Keep it short and to the point. 0.5. What is the ratio of the No. of subscribers (per 100 people) in Least developed countries in 2008 to that in 2009?
Your response must be concise. 0.82. What is the ratio of the No. of subscribers (per 100 people) in Brazil in 2008 to that in 2009?
Ensure brevity in your answer.  0.9. What is the ratio of the No. of subscribers (per 100 people) in Sri Lanka in 2008 to that in 2009?
Ensure brevity in your answer.  0.68. What is the difference between the highest and the second highest No. of subscribers (per 100 people) of Least developed countries?
Provide a short and direct response. 4.84. What is the difference between the highest and the second highest No. of subscribers (per 100 people) of Brazil?
Give a very brief answer. 8.99. What is the difference between the highest and the second highest No. of subscribers (per 100 people) of Sri Lanka?
Make the answer very short. 24.96. What is the difference between the highest and the lowest No. of subscribers (per 100 people) of Least developed countries?
Your answer should be compact. 25.47. What is the difference between the highest and the lowest No. of subscribers (per 100 people) in Brazil?
Keep it short and to the point. 68.1. What is the difference between the highest and the lowest No. of subscribers (per 100 people) in Sri Lanka?
Make the answer very short. 74.31. 